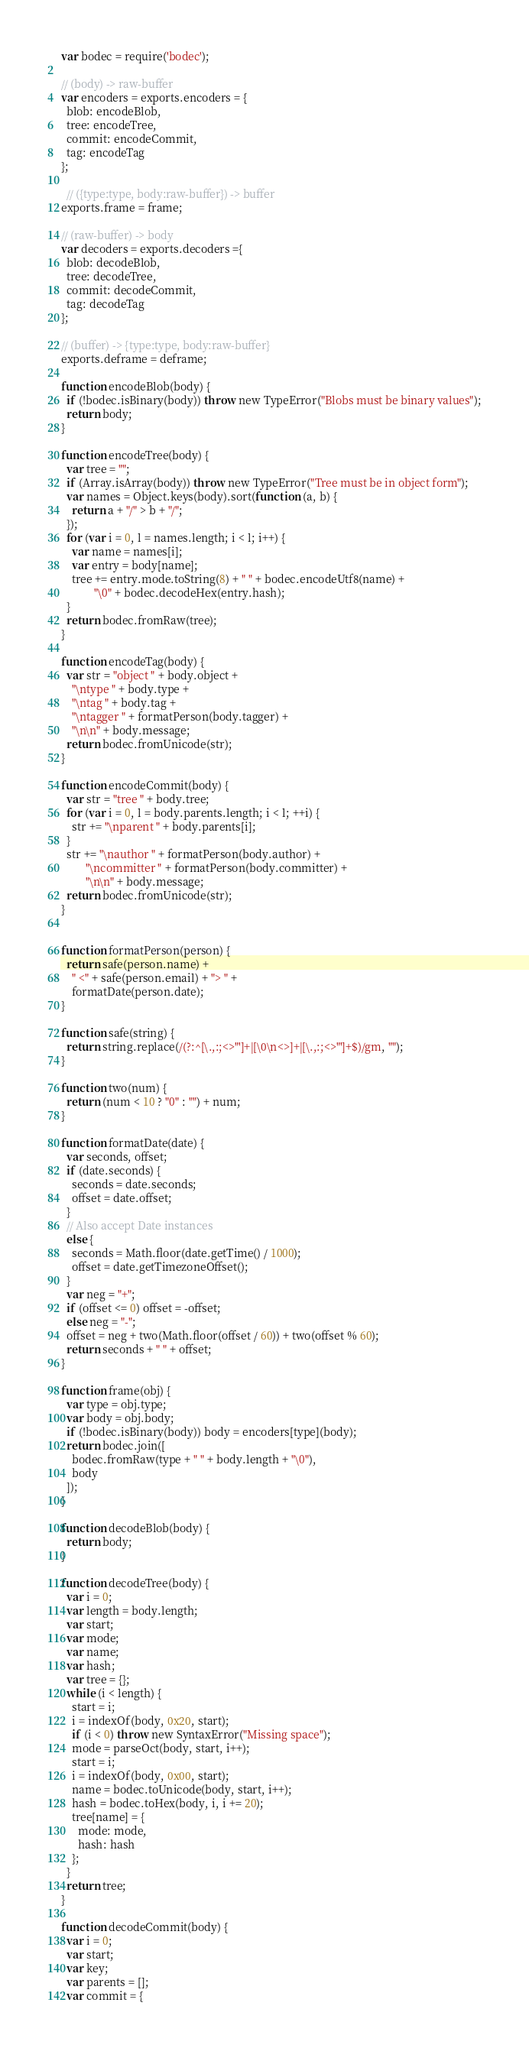Convert code to text. <code><loc_0><loc_0><loc_500><loc_500><_JavaScript_>var bodec = require('bodec');

// (body) -> raw-buffer
var encoders = exports.encoders = {
  blob: encodeBlob,
  tree: encodeTree,
  commit: encodeCommit,
  tag: encodeTag
};

  // ({type:type, body:raw-buffer}) -> buffer
exports.frame = frame;

// (raw-buffer) -> body
var decoders = exports.decoders ={
  blob: decodeBlob,
  tree: decodeTree,
  commit: decodeCommit,
  tag: decodeTag
};

// (buffer) -> {type:type, body:raw-buffer}
exports.deframe = deframe;

function encodeBlob(body) {
  if (!bodec.isBinary(body)) throw new TypeError("Blobs must be binary values");
  return body;
}

function encodeTree(body) {
  var tree = "";
  if (Array.isArray(body)) throw new TypeError("Tree must be in object form");
  var names = Object.keys(body).sort(function (a, b) {
    return a + "/" > b + "/";
  });
  for (var i = 0, l = names.length; i < l; i++) {
    var name = names[i];
    var entry = body[name];
    tree += entry.mode.toString(8) + " " + bodec.encodeUtf8(name) +
            "\0" + bodec.decodeHex(entry.hash);
  }
  return bodec.fromRaw(tree);
}

function encodeTag(body) {
  var str = "object " + body.object +
    "\ntype " + body.type +
    "\ntag " + body.tag +
    "\ntagger " + formatPerson(body.tagger) +
    "\n\n" + body.message;
  return bodec.fromUnicode(str);
}

function encodeCommit(body) {
  var str = "tree " + body.tree;
  for (var i = 0, l = body.parents.length; i < l; ++i) {
    str += "\nparent " + body.parents[i];
  }
  str += "\nauthor " + formatPerson(body.author) +
         "\ncommitter " + formatPerson(body.committer) +
         "\n\n" + body.message;
  return bodec.fromUnicode(str);
}


function formatPerson(person) {
  return safe(person.name) +
    " <" + safe(person.email) + "> " +
    formatDate(person.date);
}

function safe(string) {
  return string.replace(/(?:^[\.,:;<>"']+|[\0\n<>]+|[\.,:;<>"']+$)/gm, "");
}

function two(num) {
  return (num < 10 ? "0" : "") + num;
}

function formatDate(date) {
  var seconds, offset;
  if (date.seconds) {
    seconds = date.seconds;
    offset = date.offset;
  }
  // Also accept Date instances
  else {
    seconds = Math.floor(date.getTime() / 1000);
    offset = date.getTimezoneOffset();
  }
  var neg = "+";
  if (offset <= 0) offset = -offset;
  else neg = "-";
  offset = neg + two(Math.floor(offset / 60)) + two(offset % 60);
  return seconds + " " + offset;
}

function frame(obj) {
  var type = obj.type;
  var body = obj.body;
  if (!bodec.isBinary(body)) body = encoders[type](body);
  return bodec.join([
    bodec.fromRaw(type + " " + body.length + "\0"),
    body
  ]);
}

function decodeBlob(body) {
  return body;
}

function decodeTree(body) {
  var i = 0;
  var length = body.length;
  var start;
  var mode;
  var name;
  var hash;
  var tree = {};
  while (i < length) {
    start = i;
    i = indexOf(body, 0x20, start);
    if (i < 0) throw new SyntaxError("Missing space");
    mode = parseOct(body, start, i++);
    start = i;
    i = indexOf(body, 0x00, start);
    name = bodec.toUnicode(body, start, i++);
    hash = bodec.toHex(body, i, i += 20);
    tree[name] = {
      mode: mode,
      hash: hash
    };
  }
  return tree;
}

function decodeCommit(body) {
  var i = 0;
  var start;
  var key;
  var parents = [];
  var commit = {</code> 